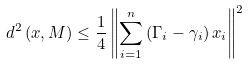Convert formula to latex. <formula><loc_0><loc_0><loc_500><loc_500>d ^ { 2 } \left ( x , M \right ) \leq \frac { 1 } { 4 } \left \| \sum _ { i = 1 } ^ { n } \left ( \Gamma _ { i } - \gamma _ { i } \right ) x _ { i } \right \| ^ { 2 }</formula> 